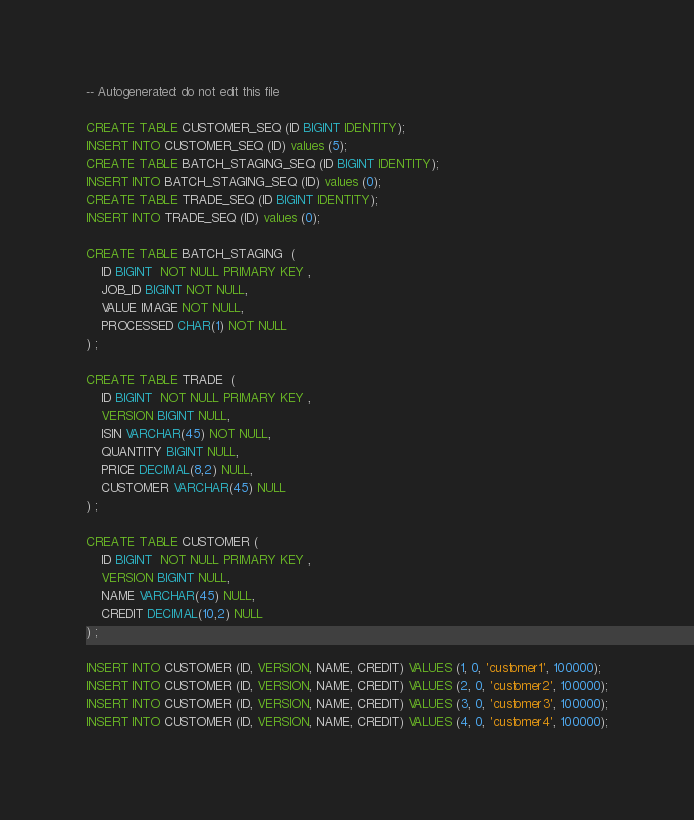<code> <loc_0><loc_0><loc_500><loc_500><_SQL_>-- Autogenerated: do not edit this file

CREATE TABLE CUSTOMER_SEQ (ID BIGINT IDENTITY);
INSERT INTO CUSTOMER_SEQ (ID) values (5);
CREATE TABLE BATCH_STAGING_SEQ (ID BIGINT IDENTITY);
INSERT INTO BATCH_STAGING_SEQ (ID) values (0);
CREATE TABLE TRADE_SEQ (ID BIGINT IDENTITY);
INSERT INTO TRADE_SEQ (ID) values (0);

CREATE TABLE BATCH_STAGING  (
	ID BIGINT  NOT NULL PRIMARY KEY ,  
	JOB_ID BIGINT NOT NULL,
	VALUE IMAGE NOT NULL,
	PROCESSED CHAR(1) NOT NULL
) ;

CREATE TABLE TRADE  (
	ID BIGINT  NOT NULL PRIMARY KEY ,  
	VERSION BIGINT NULL,
	ISIN VARCHAR(45) NOT NULL, 
	QUANTITY BIGINT NULL,
	PRICE DECIMAL(8,2) NULL, 
	CUSTOMER VARCHAR(45) NULL
) ;
 
CREATE TABLE CUSTOMER (
	ID BIGINT  NOT NULL PRIMARY KEY ,  
	VERSION BIGINT NULL,
	NAME VARCHAR(45) NULL,
	CREDIT DECIMAL(10,2) NULL
) ;
 
INSERT INTO CUSTOMER (ID, VERSION, NAME, CREDIT) VALUES (1, 0, 'customer1', 100000);
INSERT INTO CUSTOMER (ID, VERSION, NAME, CREDIT) VALUES (2, 0, 'customer2', 100000);
INSERT INTO CUSTOMER (ID, VERSION, NAME, CREDIT) VALUES (3, 0, 'customer3', 100000);
INSERT INTO CUSTOMER (ID, VERSION, NAME, CREDIT) VALUES (4, 0, 'customer4', 100000);
</code> 